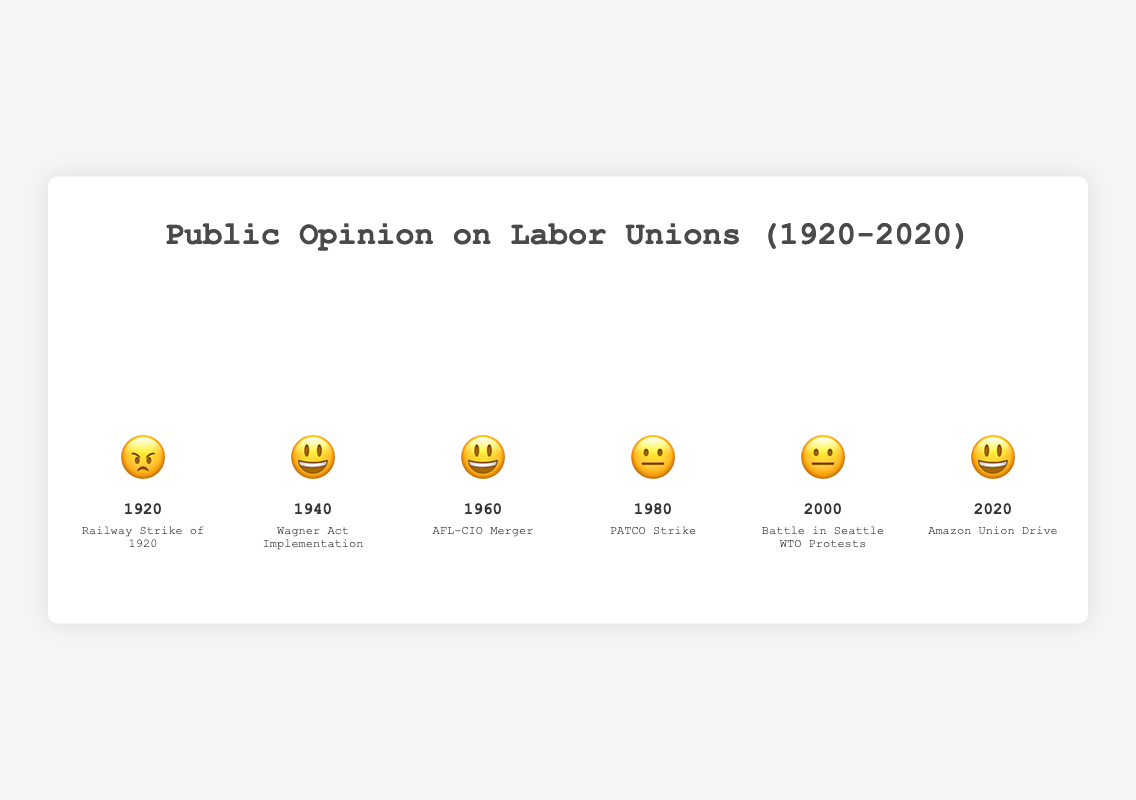What's the sentiment in 1960? The emoji for the year 1960 shows a smiling face 😃, which indicates a positive sentiment.
Answer: 😃 Which years show a neutral sentiment towards labor unions? For a neutral sentiment, we look for the 😐 emoji. According to the chart, the years 1980 and 2000 have neutral sentiments.
Answer: 1980, 2000 What significant event happened in 1940 and what was the public sentiment? In 1940, the significant event was the implementation of the Wagner Act, and the emoji 😃 indicates a positive public sentiment.
Answer: Wagner Act Implementation, 😃 How did public opinion change between 1920 and 1940? In 1920, the sentiment was negative 😠, linked to the Railway Strike of 1920. By 1940, the sentiment had changed to positive 😃 due to the Wagner Act Implementation. This shows an improvement in public opinion over these two decades.
Answer: Negative to Positive Compare the public sentiment in 1960 and 1980. The emoji for 1960 is a smiling face 😃, indicating a positive sentiment, while the emoji for 1980 is neutral 😐. Therefore, public sentiment was more positive in 1960 compared to 1980.
Answer: More positive in 1960 What event is associated with the positive sentiment in 2020? The emoji 😃 for the year 2020 indicates a positive sentiment and is associated with the Amazon Union Drive.
Answer: Amazon Union Drive Which decade had the most positive sentiment and what was the key event? The emoji 😃 represents positive sentiment, and these emojis appear for the years 1940, 1960, and 2020. However, in this provided data, each of these years belongs to different decades. Thus, each decade has its own key positive event: 1940 had the Wagner Act Implementation, 1960 had the AFL-CIO Merger, and 2020 had the Amazon Union Drive.
Answer: 1940, 1960, 2020 each had positive sentiments How many years have a positive sentiment toward labor unions? The positive sentiment is represented by the emoji 😃. According to the chart, the years 1940, 1960, and 2020 have positive sentiments. Therefore, there are 3 years with a positive sentiment.
Answer: 3 